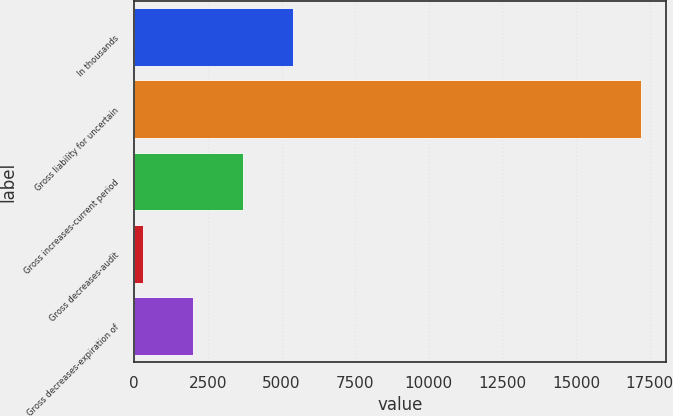Convert chart. <chart><loc_0><loc_0><loc_500><loc_500><bar_chart><fcel>In thousands<fcel>Gross liability for uncertain<fcel>Gross increases-current period<fcel>Gross decreases-audit<fcel>Gross decreases-expiration of<nl><fcel>5371.6<fcel>17203<fcel>3681.4<fcel>301<fcel>1991.2<nl></chart> 